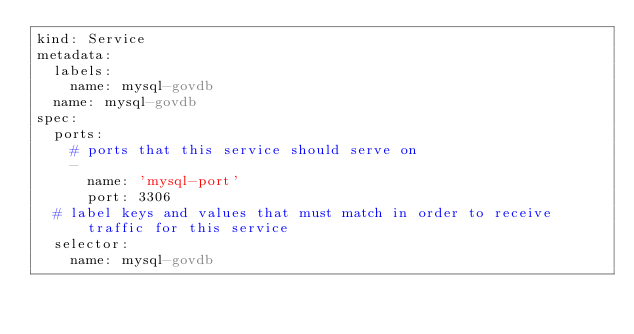Convert code to text. <code><loc_0><loc_0><loc_500><loc_500><_YAML_>kind: Service
metadata:
  labels:
    name: mysql-govdb
  name: mysql-govdb
spec:
  ports:
    # ports that this service should serve on
    -
      name: 'mysql-port'
      port: 3306
  # label keys and values that must match in order to receive traffic for this service
  selector:
    name: mysql-govdb
</code> 